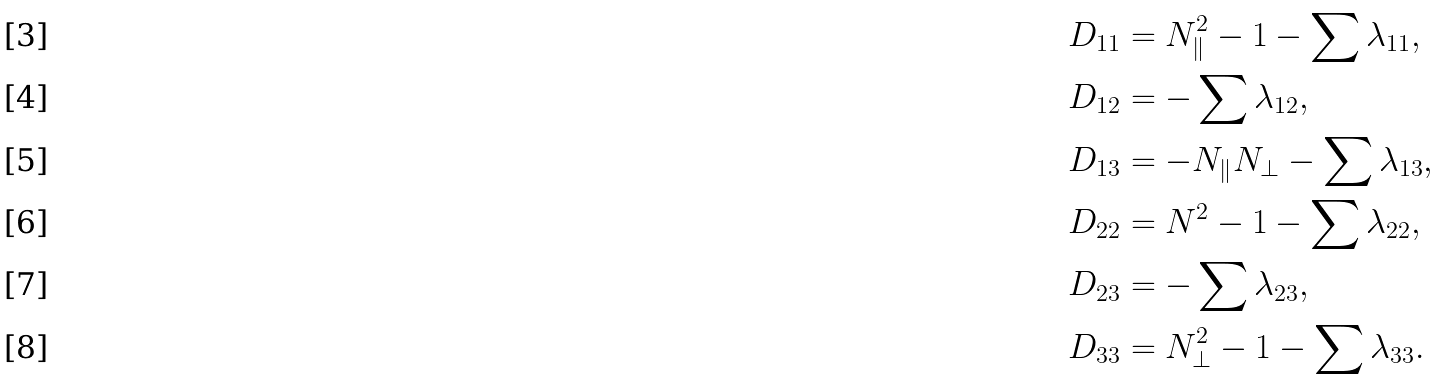Convert formula to latex. <formula><loc_0><loc_0><loc_500><loc_500>& D _ { 1 1 } = N _ { \| } ^ { 2 } - 1 - \sum \lambda _ { 1 1 } , \\ & D _ { 1 2 } = - \sum \lambda _ { 1 2 } , \\ & D _ { 1 3 } = - N _ { \| } N _ { \perp } - \sum \lambda _ { 1 3 } , \\ & D _ { 2 2 } = N ^ { 2 } - 1 - \sum \lambda _ { 2 2 } , \\ & D _ { 2 3 } = - \sum \lambda _ { 2 3 } , \\ & D _ { 3 3 } = N _ { \perp } ^ { 2 } - 1 - \sum \lambda _ { 3 3 } .</formula> 